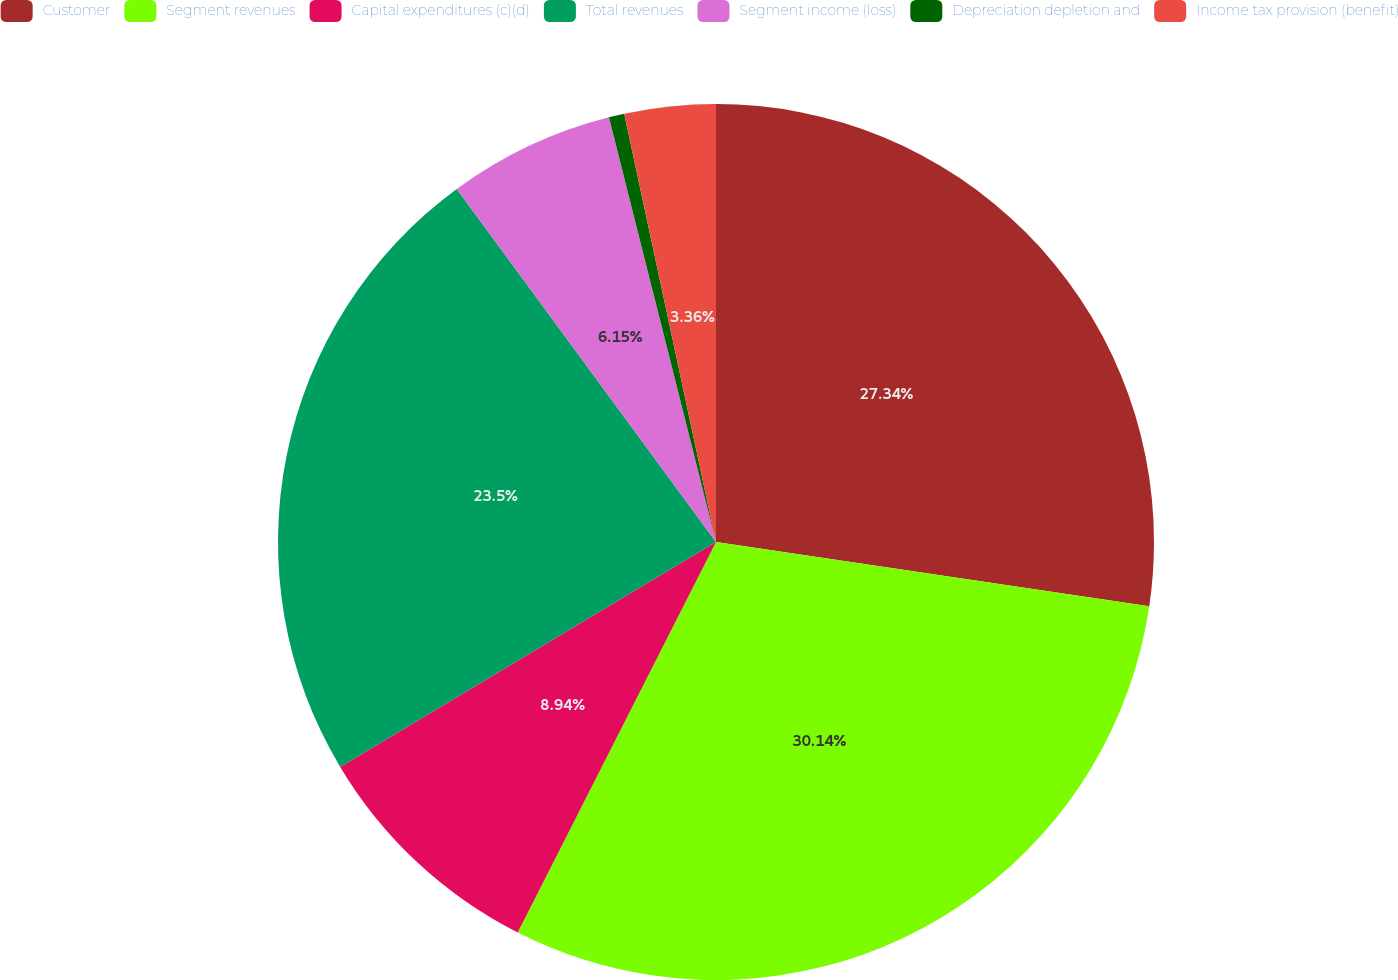<chart> <loc_0><loc_0><loc_500><loc_500><pie_chart><fcel>Customer<fcel>Segment revenues<fcel>Capital expenditures (c)(d)<fcel>Total revenues<fcel>Segment income (loss)<fcel>Depreciation depletion and<fcel>Income tax provision (benefit)<nl><fcel>27.34%<fcel>30.13%<fcel>8.94%<fcel>23.5%<fcel>6.15%<fcel>0.57%<fcel>3.36%<nl></chart> 